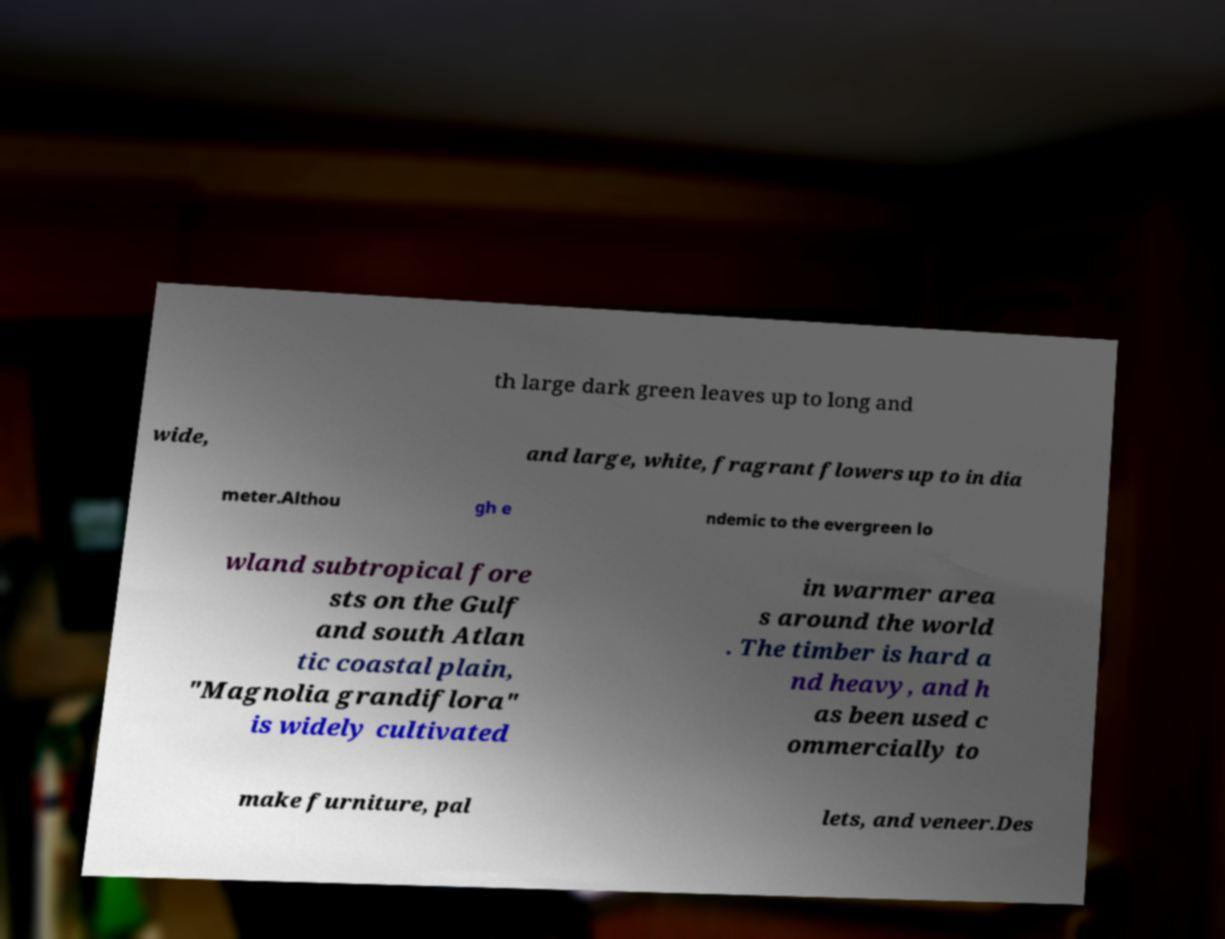What messages or text are displayed in this image? I need them in a readable, typed format. th large dark green leaves up to long and wide, and large, white, fragrant flowers up to in dia meter.Althou gh e ndemic to the evergreen lo wland subtropical fore sts on the Gulf and south Atlan tic coastal plain, "Magnolia grandiflora" is widely cultivated in warmer area s around the world . The timber is hard a nd heavy, and h as been used c ommercially to make furniture, pal lets, and veneer.Des 